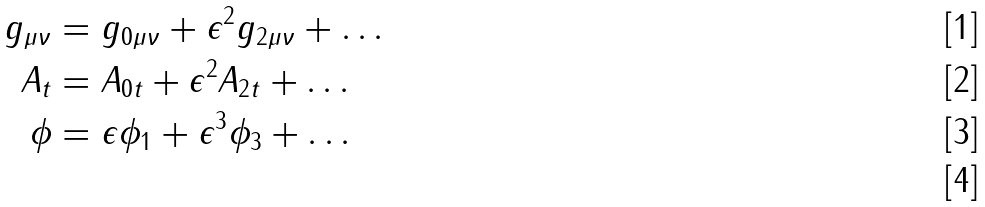Convert formula to latex. <formula><loc_0><loc_0><loc_500><loc_500>g _ { \mu \nu } & = g _ { 0 \mu \nu } + \epsilon ^ { 2 } g _ { 2 \mu \nu } + \dots \\ A _ { t } & = A _ { 0 t } + \epsilon ^ { 2 } A _ { 2 t } + \dots \\ \phi & = \epsilon \phi _ { 1 } + \epsilon ^ { 3 } \phi _ { 3 } + \dots \\</formula> 